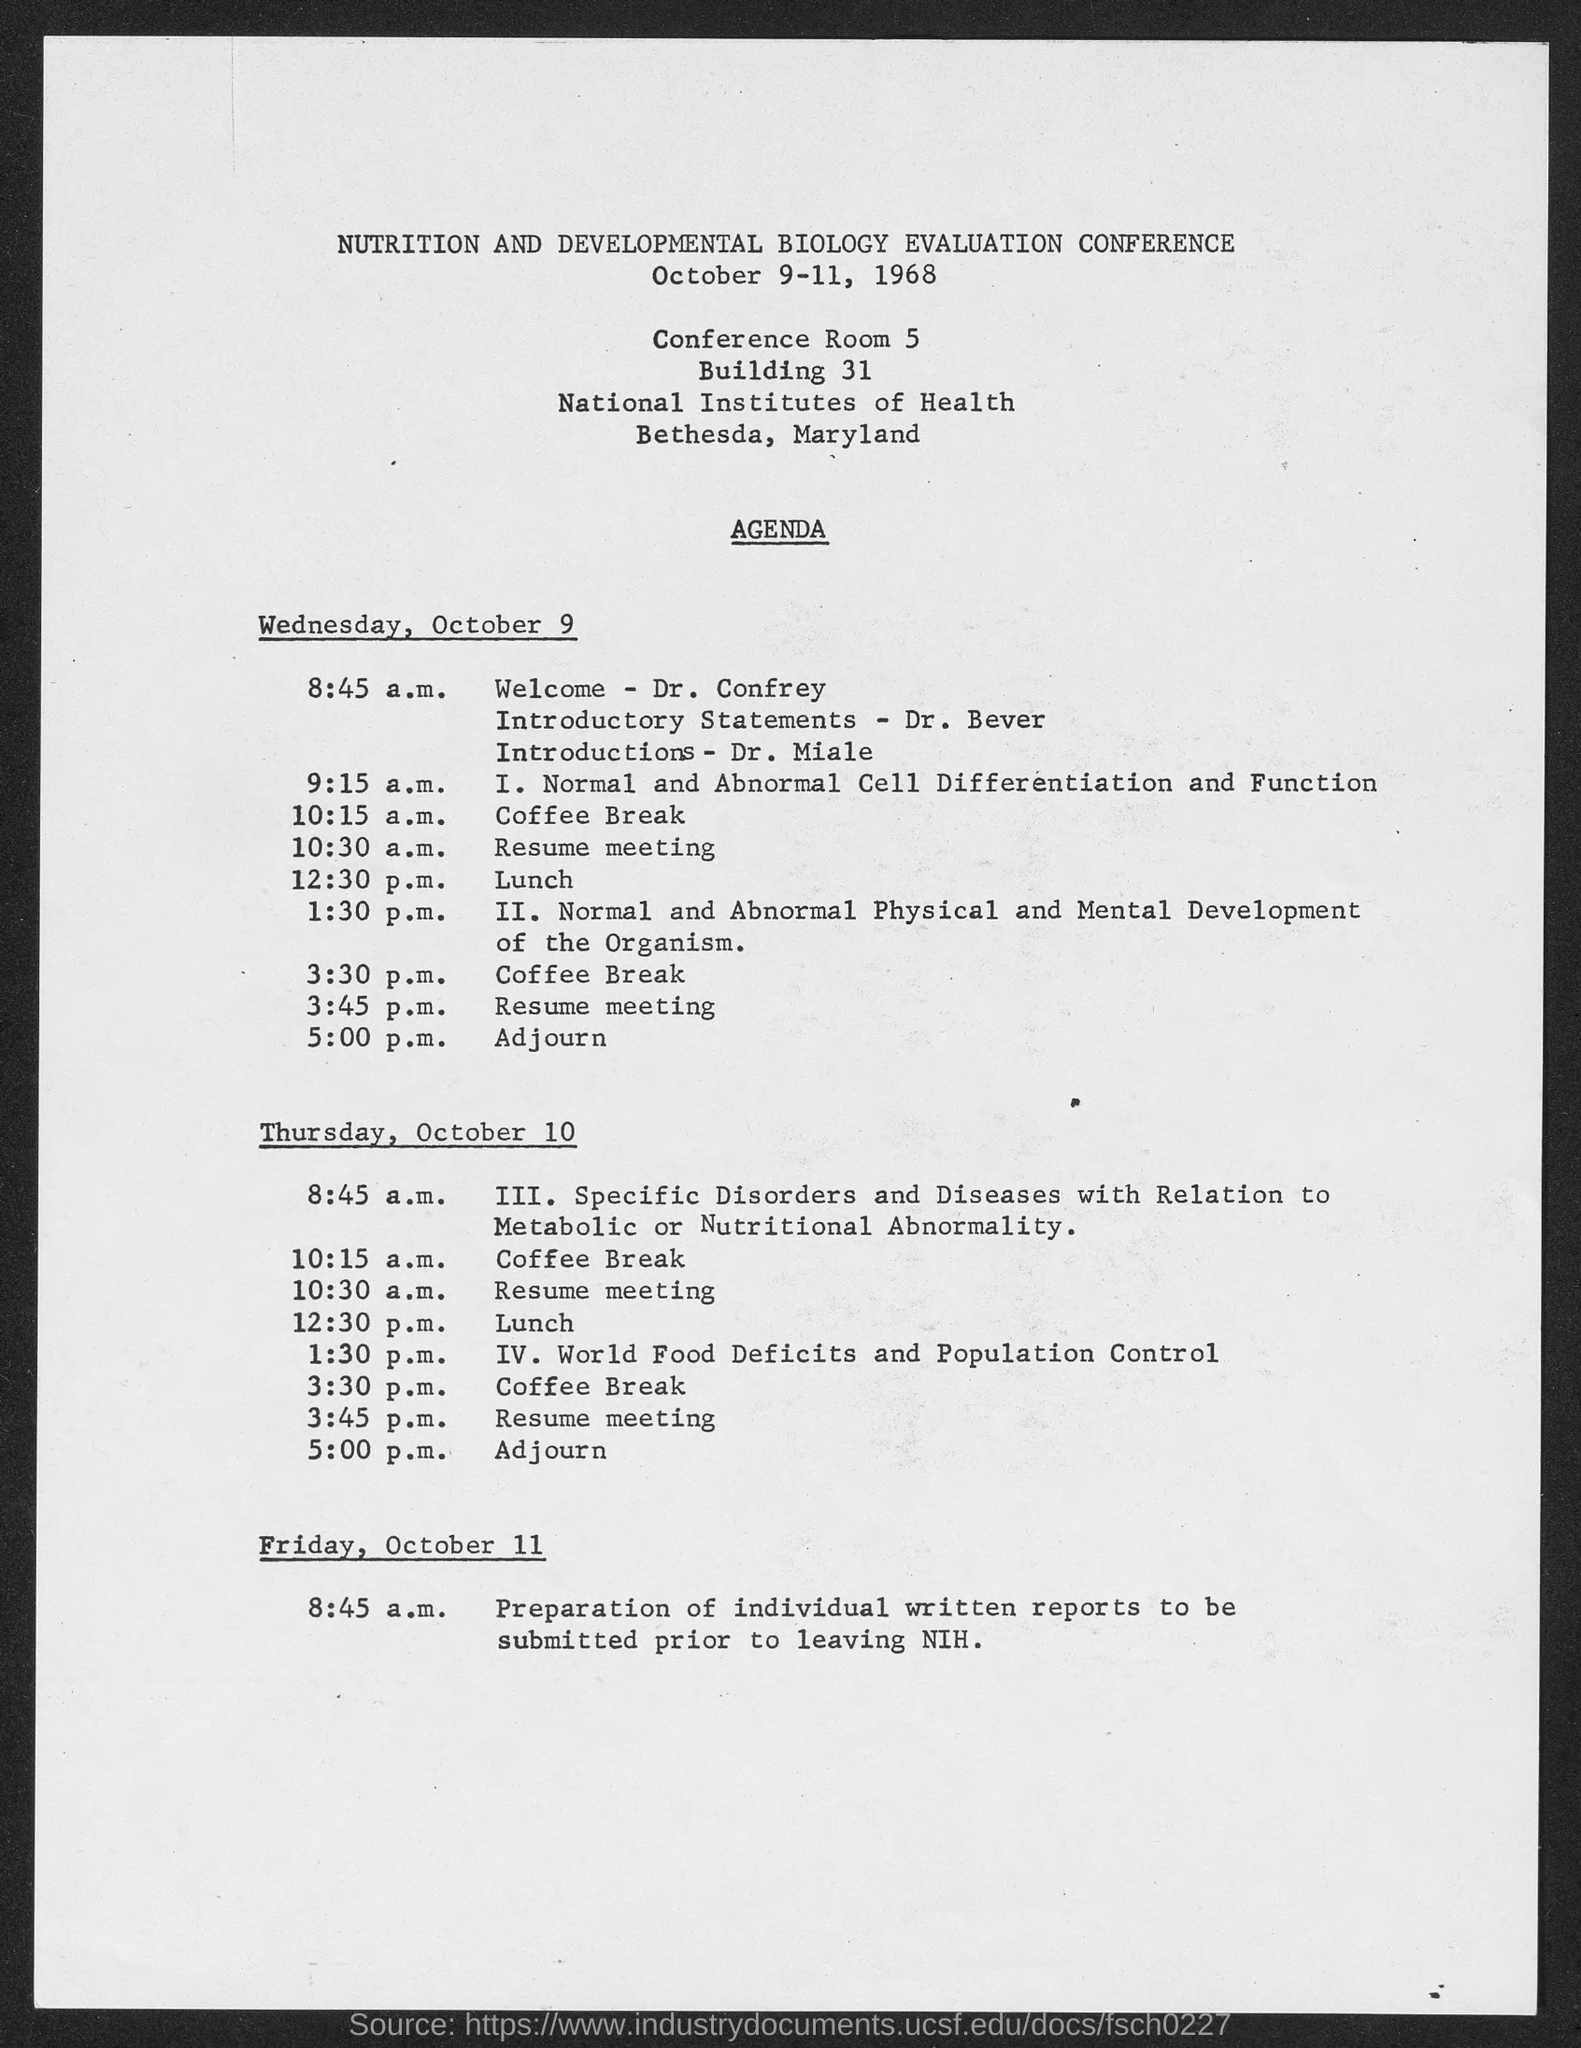Give some essential details in this illustration. The conference is held in October, which is the tenth month of the year. The title of the conference is "Nutrition and Development Biology Evaluation Conference. The conference was held in the year 1968. On Wednesday, October 9, the lunch will be held at 12:30 P.M. It is announced that Dr. Confrey will deliver the welcome speech on Wednesday, October 9. 